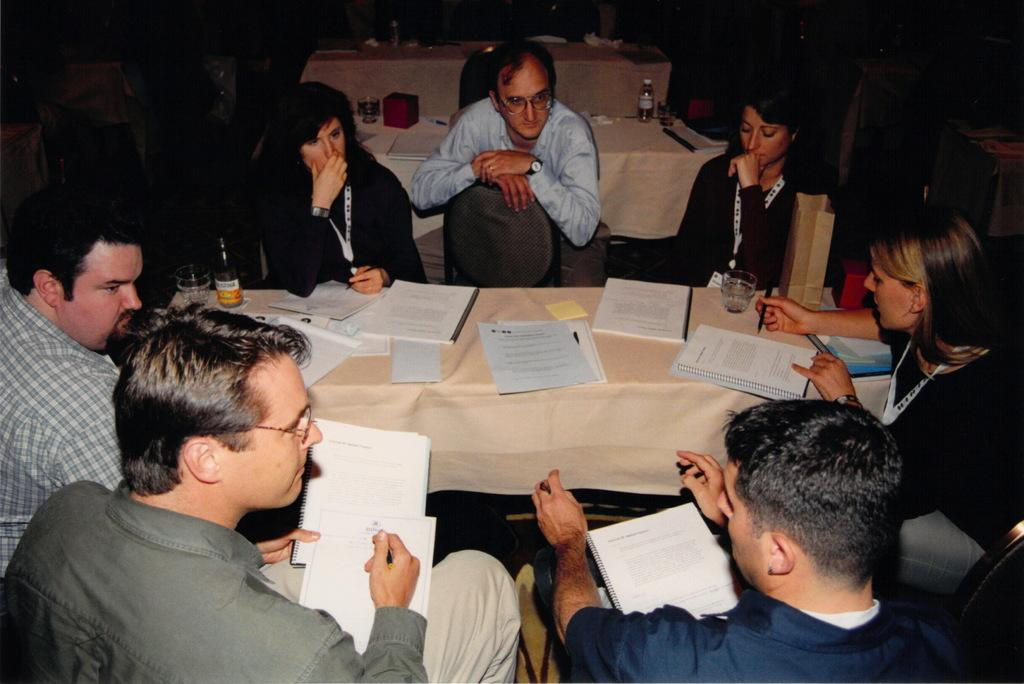How many people are in the image? There is a group of people in the image. What are the people doing in the image? The people are sitting on a chair and discussing something. What can be seen on the table in the image? Books and a glass are present on the table. What is visible in the background of the image? Tables are visible in the background of the image. What trick is the person performing with the quarter in the image? There is no trick or quarter present in the image. Whose birthday is being celebrated in the image? There is no indication of a birthday celebration in the image. 